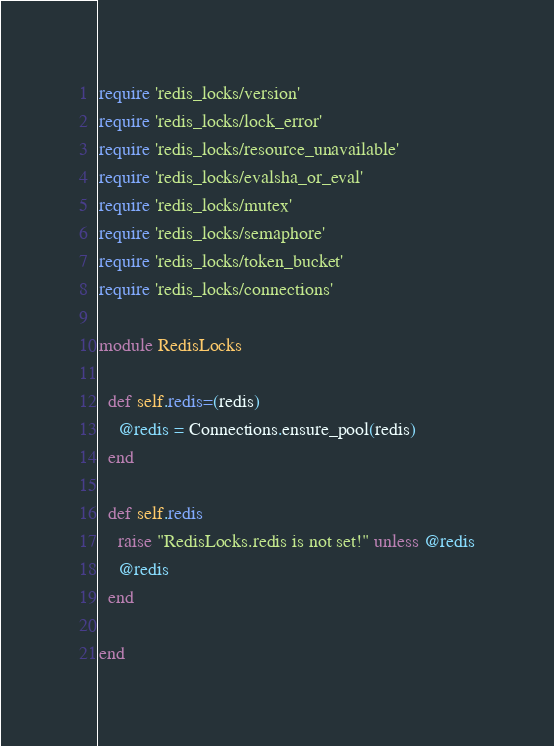Convert code to text. <code><loc_0><loc_0><loc_500><loc_500><_Ruby_>require 'redis_locks/version'
require 'redis_locks/lock_error'
require 'redis_locks/resource_unavailable'
require 'redis_locks/evalsha_or_eval'
require 'redis_locks/mutex'
require 'redis_locks/semaphore'
require 'redis_locks/token_bucket'
require 'redis_locks/connections'

module RedisLocks

  def self.redis=(redis)
    @redis = Connections.ensure_pool(redis)
  end

  def self.redis
    raise "RedisLocks.redis is not set!" unless @redis
    @redis
  end

end
</code> 